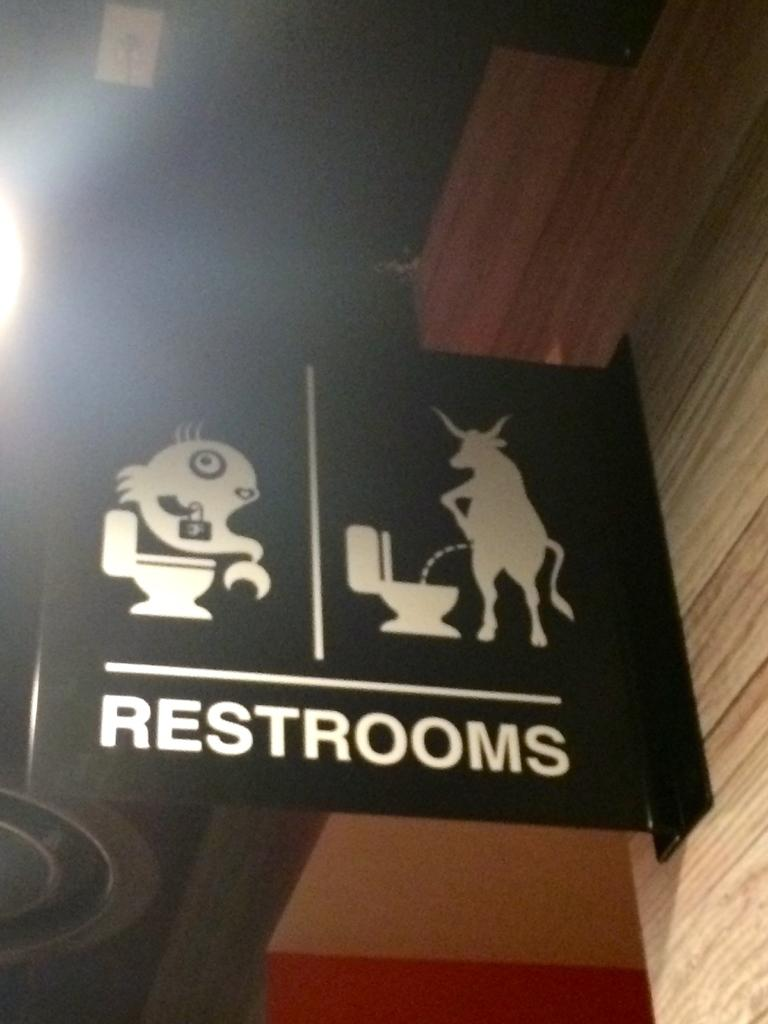What is on the wall in the image? There is a black color board on the wall. What is written on the color board? The word "restrooms" is written on the board. Is there any source of light near the color board? Yes, there is a light to the left of the board. How many ladybugs are crawling on the color board in the image? There are no ladybugs present on the color board in the image. What type of plate is placed on the floor near the light? There is no plate present in the image. 